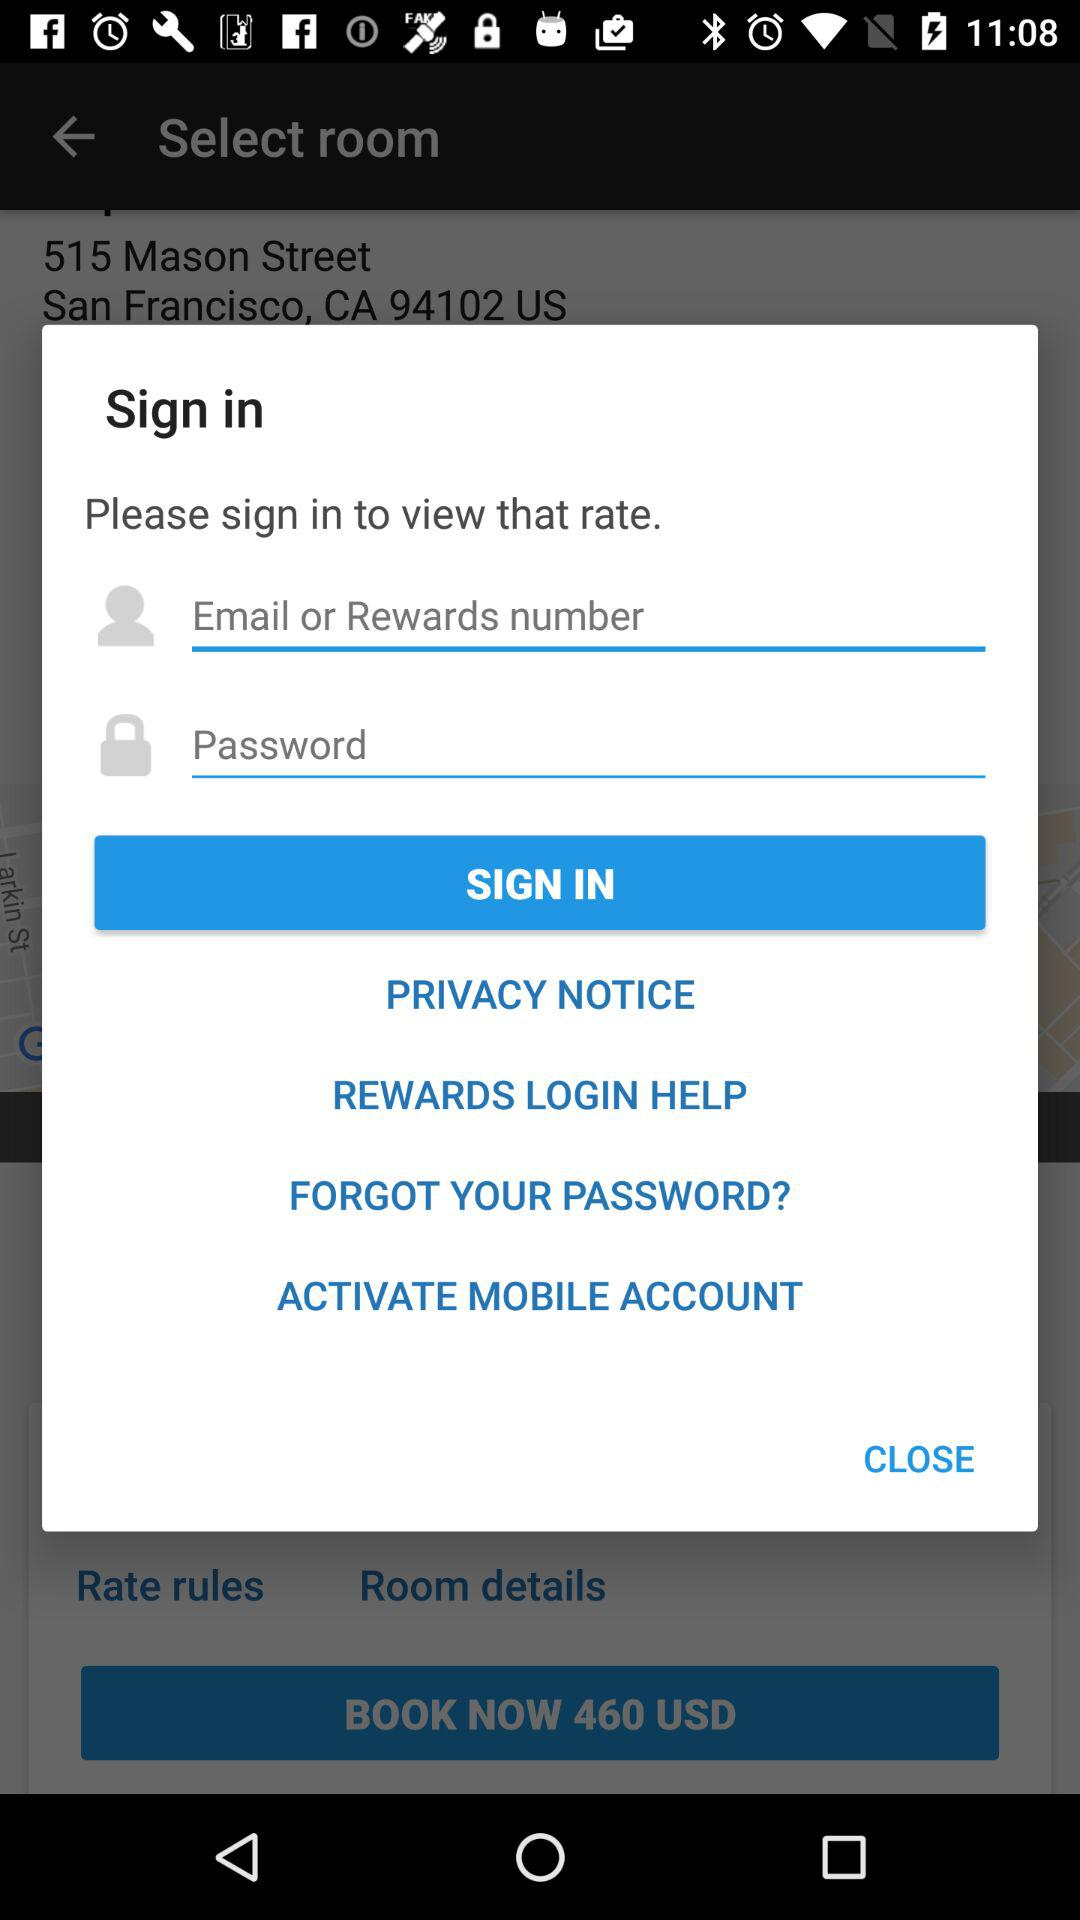What is the currency of the room booking price? The currency is US dollars. 